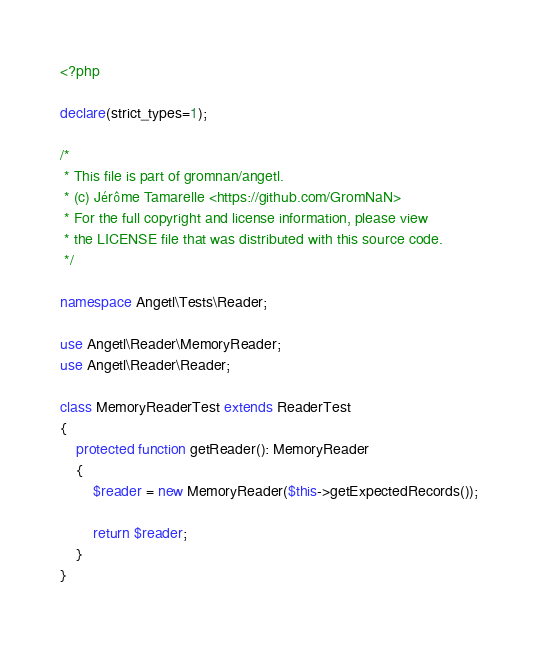<code> <loc_0><loc_0><loc_500><loc_500><_PHP_><?php

declare(strict_types=1);

/*
 * This file is part of gromnan/angetl.
 * (c) Jérôme Tamarelle <https://github.com/GromNaN>
 * For the full copyright and license information, please view
 * the LICENSE file that was distributed with this source code.
 */

namespace Angetl\Tests\Reader;

use Angetl\Reader\MemoryReader;
use Angetl\Reader\Reader;

class MemoryReaderTest extends ReaderTest
{
    protected function getReader(): MemoryReader
    {
        $reader = new MemoryReader($this->getExpectedRecords());

        return $reader;
    }
}
</code> 